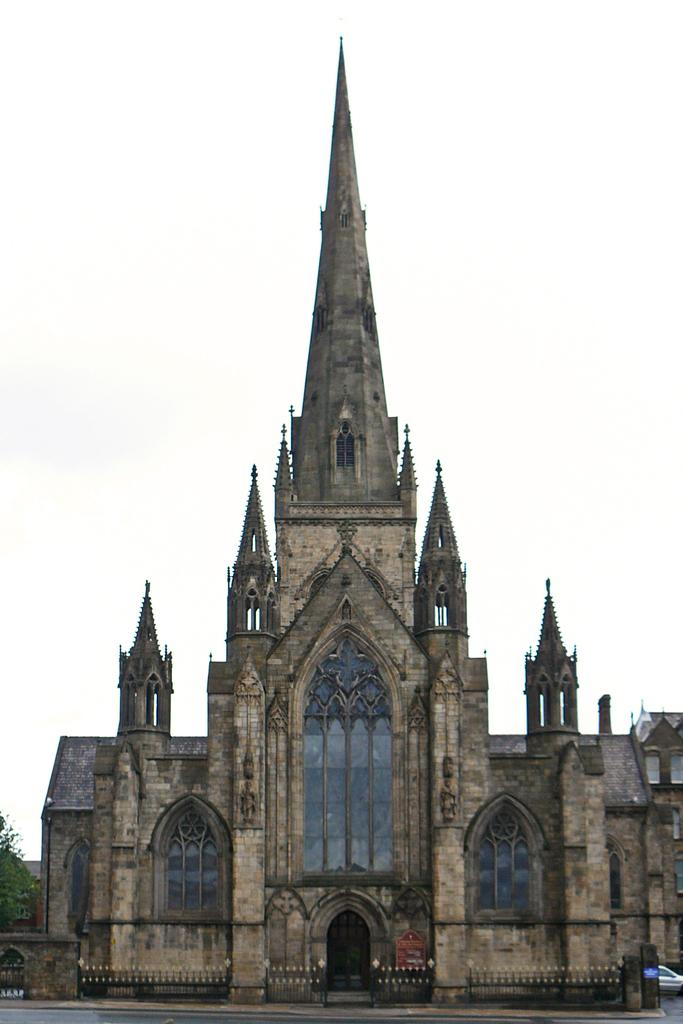What type of structure is present in the image? There is a building in the image. What other natural element can be seen in the image? There is a tree in the image. Is there any mode of transportation visible in the image? Yes, there is a vehicle in the image. What part of the natural environment is visible in the image? The sky is visible in the image. How many pickles are hanging from the tree in the image? There are no pickles present in the image; it features a building, a tree, a vehicle, and the sky. What direction is the wind blowing in the image? There is no indication of wind direction in the image, as it does not depict any movement or blowing objects. 